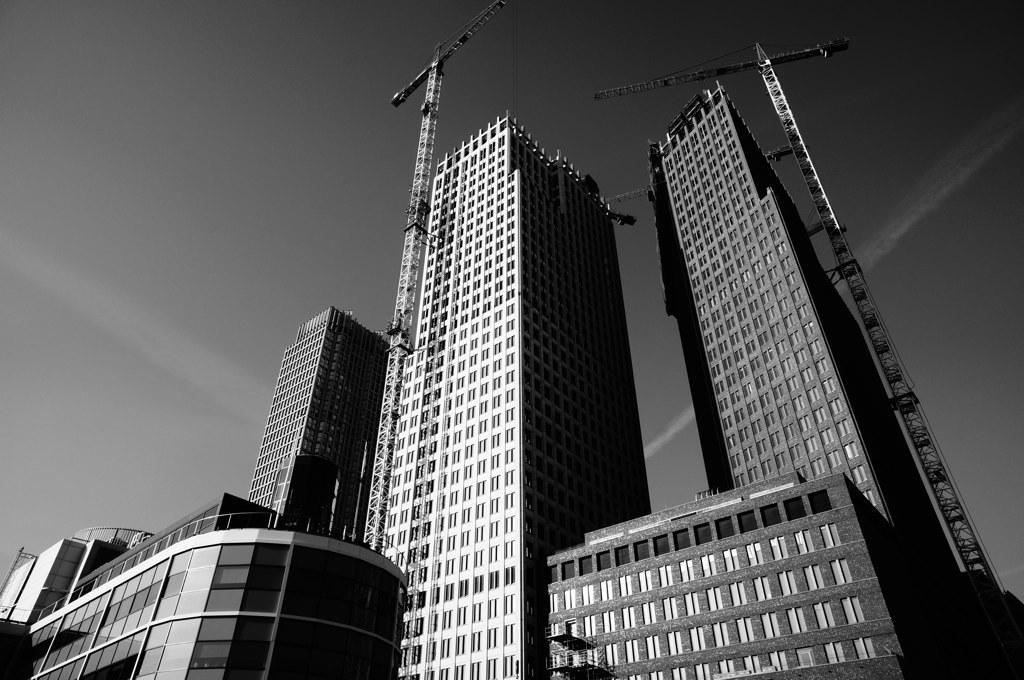What is the color scheme of the image? The image is black and white. What type of structures can be seen in the image? There are buildings in the image. What machinery is present in the image? There are cranes in the image. What part of the natural environment is visible in the image? The sky is visible in the image. How many drawers are visible in the image? There are no drawers present in the image. What type of building is shown in the image? The image does not show a specific type of building; it only shows buildings in general. 